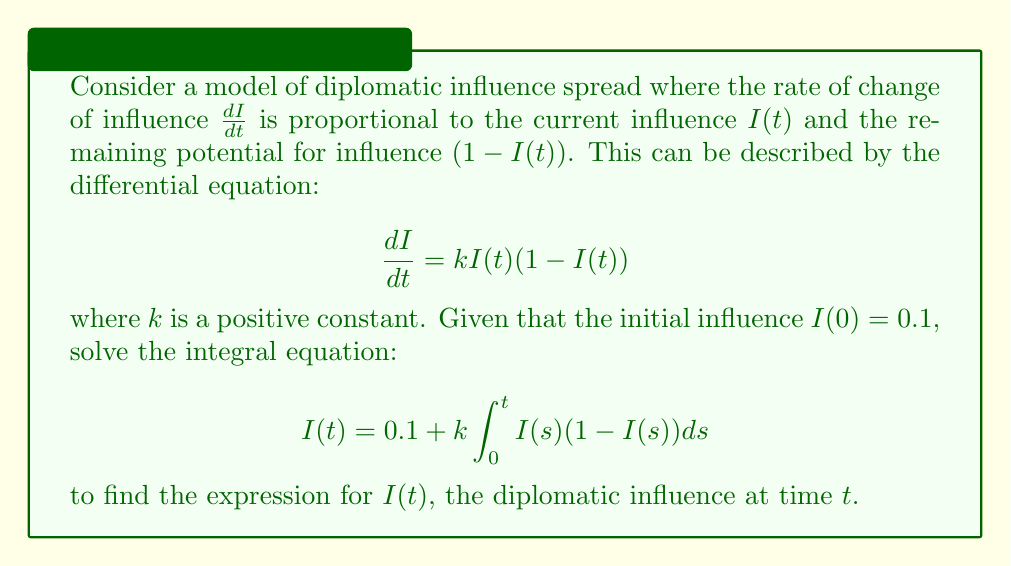What is the answer to this math problem? To solve this integral equation, we'll follow these steps:

1) First, we recognize that this is a separable differential equation. We can rewrite it as:

   $$\frac{dI}{I(1-I)} = kdt$$

2) Integrate both sides:

   $$\int \frac{dI}{I(1-I)} = \int kdt$$

3) The left side can be integrated using partial fractions:

   $$\int \frac{dI}{I(1-I)} = \int (\frac{1}{I} + \frac{1}{1-I})dI = \ln|I| - \ln|1-I| + C$$

4) The right side integrates to:

   $$\int kdt = kt + C'$$

5) Combining these results:

   $$\ln|I| - \ln|1-I| = kt + C''$$

6) Simplify using properties of logarithms:

   $$\ln|\frac{I}{1-I}| = kt + C''$$

7) Exponentiate both sides:

   $$\frac{I}{1-I} = Ce^{kt}$$

   where $C = e^{C''}$ is a new constant.

8) Solve for $I$:

   $$I = \frac{Ce^{kt}}{1+Ce^{kt}}$$

9) Use the initial condition $I(0) = 0.1$ to find $C$:

   $$0.1 = \frac{C}{1+C}$$
   
   $$C = \frac{1}{9}$$

10) Substitute this back into our solution:

    $$I(t) = \frac{\frac{1}{9}e^{kt}}{1+\frac{1}{9}e^{kt}} = \frac{e^{kt}}{9+e^{kt}}$$

This is the final expression for $I(t)$, representing the diplomatic influence at time $t$.
Answer: $I(t) = \frac{e^{kt}}{9+e^{kt}}$ 